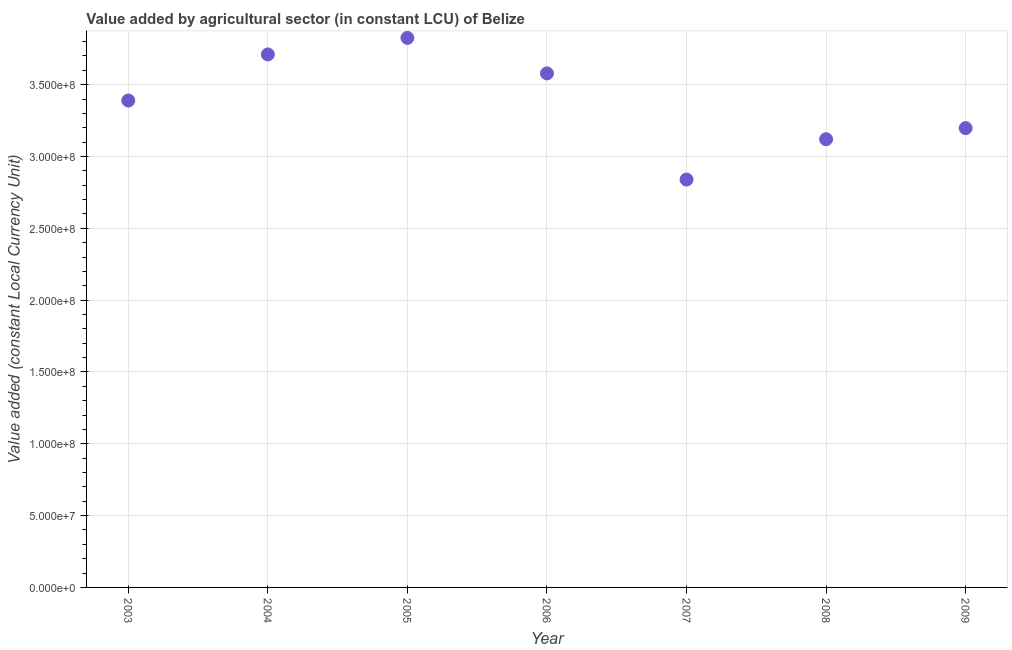What is the value added by agriculture sector in 2009?
Provide a short and direct response. 3.20e+08. Across all years, what is the maximum value added by agriculture sector?
Keep it short and to the point. 3.83e+08. Across all years, what is the minimum value added by agriculture sector?
Your answer should be very brief. 2.84e+08. In which year was the value added by agriculture sector minimum?
Your answer should be compact. 2007. What is the sum of the value added by agriculture sector?
Give a very brief answer. 2.37e+09. What is the difference between the value added by agriculture sector in 2005 and 2008?
Make the answer very short. 7.05e+07. What is the average value added by agriculture sector per year?
Provide a short and direct response. 3.38e+08. What is the median value added by agriculture sector?
Offer a very short reply. 3.39e+08. What is the ratio of the value added by agriculture sector in 2003 to that in 2005?
Provide a short and direct response. 0.89. Is the value added by agriculture sector in 2005 less than that in 2006?
Your answer should be compact. No. What is the difference between the highest and the second highest value added by agriculture sector?
Ensure brevity in your answer.  1.15e+07. What is the difference between the highest and the lowest value added by agriculture sector?
Provide a short and direct response. 9.86e+07. How many years are there in the graph?
Give a very brief answer. 7. Are the values on the major ticks of Y-axis written in scientific E-notation?
Provide a succinct answer. Yes. Does the graph contain any zero values?
Make the answer very short. No. Does the graph contain grids?
Provide a succinct answer. Yes. What is the title of the graph?
Your answer should be compact. Value added by agricultural sector (in constant LCU) of Belize. What is the label or title of the X-axis?
Your response must be concise. Year. What is the label or title of the Y-axis?
Your answer should be very brief. Value added (constant Local Currency Unit). What is the Value added (constant Local Currency Unit) in 2003?
Make the answer very short. 3.39e+08. What is the Value added (constant Local Currency Unit) in 2004?
Make the answer very short. 3.71e+08. What is the Value added (constant Local Currency Unit) in 2005?
Your answer should be compact. 3.83e+08. What is the Value added (constant Local Currency Unit) in 2006?
Provide a short and direct response. 3.58e+08. What is the Value added (constant Local Currency Unit) in 2007?
Offer a very short reply. 2.84e+08. What is the Value added (constant Local Currency Unit) in 2008?
Offer a terse response. 3.12e+08. What is the Value added (constant Local Currency Unit) in 2009?
Give a very brief answer. 3.20e+08. What is the difference between the Value added (constant Local Currency Unit) in 2003 and 2004?
Your answer should be very brief. -3.21e+07. What is the difference between the Value added (constant Local Currency Unit) in 2003 and 2005?
Your response must be concise. -4.36e+07. What is the difference between the Value added (constant Local Currency Unit) in 2003 and 2006?
Provide a short and direct response. -1.89e+07. What is the difference between the Value added (constant Local Currency Unit) in 2003 and 2007?
Ensure brevity in your answer.  5.50e+07. What is the difference between the Value added (constant Local Currency Unit) in 2003 and 2008?
Your answer should be very brief. 2.70e+07. What is the difference between the Value added (constant Local Currency Unit) in 2003 and 2009?
Give a very brief answer. 1.92e+07. What is the difference between the Value added (constant Local Currency Unit) in 2004 and 2005?
Ensure brevity in your answer.  -1.15e+07. What is the difference between the Value added (constant Local Currency Unit) in 2004 and 2006?
Make the answer very short. 1.32e+07. What is the difference between the Value added (constant Local Currency Unit) in 2004 and 2007?
Make the answer very short. 8.71e+07. What is the difference between the Value added (constant Local Currency Unit) in 2004 and 2008?
Give a very brief answer. 5.90e+07. What is the difference between the Value added (constant Local Currency Unit) in 2004 and 2009?
Keep it short and to the point. 5.13e+07. What is the difference between the Value added (constant Local Currency Unit) in 2005 and 2006?
Offer a very short reply. 2.47e+07. What is the difference between the Value added (constant Local Currency Unit) in 2005 and 2007?
Provide a short and direct response. 9.86e+07. What is the difference between the Value added (constant Local Currency Unit) in 2005 and 2008?
Offer a very short reply. 7.05e+07. What is the difference between the Value added (constant Local Currency Unit) in 2005 and 2009?
Your answer should be very brief. 6.28e+07. What is the difference between the Value added (constant Local Currency Unit) in 2006 and 2007?
Ensure brevity in your answer.  7.39e+07. What is the difference between the Value added (constant Local Currency Unit) in 2006 and 2008?
Offer a terse response. 4.58e+07. What is the difference between the Value added (constant Local Currency Unit) in 2006 and 2009?
Make the answer very short. 3.81e+07. What is the difference between the Value added (constant Local Currency Unit) in 2007 and 2008?
Provide a short and direct response. -2.81e+07. What is the difference between the Value added (constant Local Currency Unit) in 2007 and 2009?
Provide a succinct answer. -3.58e+07. What is the difference between the Value added (constant Local Currency Unit) in 2008 and 2009?
Offer a terse response. -7.74e+06. What is the ratio of the Value added (constant Local Currency Unit) in 2003 to that in 2004?
Your answer should be compact. 0.91. What is the ratio of the Value added (constant Local Currency Unit) in 2003 to that in 2005?
Your response must be concise. 0.89. What is the ratio of the Value added (constant Local Currency Unit) in 2003 to that in 2006?
Offer a terse response. 0.95. What is the ratio of the Value added (constant Local Currency Unit) in 2003 to that in 2007?
Your response must be concise. 1.19. What is the ratio of the Value added (constant Local Currency Unit) in 2003 to that in 2008?
Provide a short and direct response. 1.09. What is the ratio of the Value added (constant Local Currency Unit) in 2003 to that in 2009?
Give a very brief answer. 1.06. What is the ratio of the Value added (constant Local Currency Unit) in 2004 to that in 2005?
Your answer should be very brief. 0.97. What is the ratio of the Value added (constant Local Currency Unit) in 2004 to that in 2007?
Provide a short and direct response. 1.31. What is the ratio of the Value added (constant Local Currency Unit) in 2004 to that in 2008?
Give a very brief answer. 1.19. What is the ratio of the Value added (constant Local Currency Unit) in 2004 to that in 2009?
Your response must be concise. 1.16. What is the ratio of the Value added (constant Local Currency Unit) in 2005 to that in 2006?
Make the answer very short. 1.07. What is the ratio of the Value added (constant Local Currency Unit) in 2005 to that in 2007?
Make the answer very short. 1.35. What is the ratio of the Value added (constant Local Currency Unit) in 2005 to that in 2008?
Provide a short and direct response. 1.23. What is the ratio of the Value added (constant Local Currency Unit) in 2005 to that in 2009?
Your answer should be very brief. 1.2. What is the ratio of the Value added (constant Local Currency Unit) in 2006 to that in 2007?
Offer a terse response. 1.26. What is the ratio of the Value added (constant Local Currency Unit) in 2006 to that in 2008?
Your response must be concise. 1.15. What is the ratio of the Value added (constant Local Currency Unit) in 2006 to that in 2009?
Ensure brevity in your answer.  1.12. What is the ratio of the Value added (constant Local Currency Unit) in 2007 to that in 2008?
Your response must be concise. 0.91. What is the ratio of the Value added (constant Local Currency Unit) in 2007 to that in 2009?
Give a very brief answer. 0.89. 